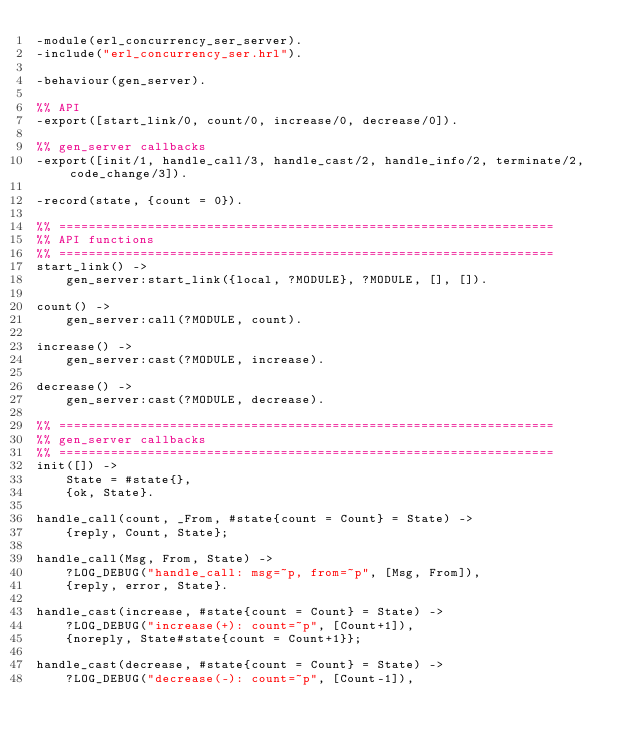<code> <loc_0><loc_0><loc_500><loc_500><_Erlang_>-module(erl_concurrency_ser_server).
-include("erl_concurrency_ser.hrl").

-behaviour(gen_server).

%% API
-export([start_link/0, count/0, increase/0, decrease/0]).

%% gen_server callbacks
-export([init/1, handle_call/3, handle_cast/2, handle_info/2, terminate/2, code_change/3]).

-record(state, {count = 0}).

%% ===================================================================
%% API functions
%% ===================================================================
start_link() ->
    gen_server:start_link({local, ?MODULE}, ?MODULE, [], []).

count() ->
    gen_server:call(?MODULE, count).

increase() ->
    gen_server:cast(?MODULE, increase).

decrease() ->
    gen_server:cast(?MODULE, decrease).

%% ===================================================================
%% gen_server callbacks
%% ===================================================================
init([]) ->
    State = #state{},
    {ok, State}.

handle_call(count, _From, #state{count = Count} = State) ->
    {reply, Count, State};

handle_call(Msg, From, State) ->
    ?LOG_DEBUG("handle_call: msg=~p, from=~p", [Msg, From]),
    {reply, error, State}.

handle_cast(increase, #state{count = Count} = State) ->
    ?LOG_DEBUG("increase(+): count=~p", [Count+1]),
    {noreply, State#state{count = Count+1}};

handle_cast(decrease, #state{count = Count} = State) ->
    ?LOG_DEBUG("decrease(-): count=~p", [Count-1]),</code> 